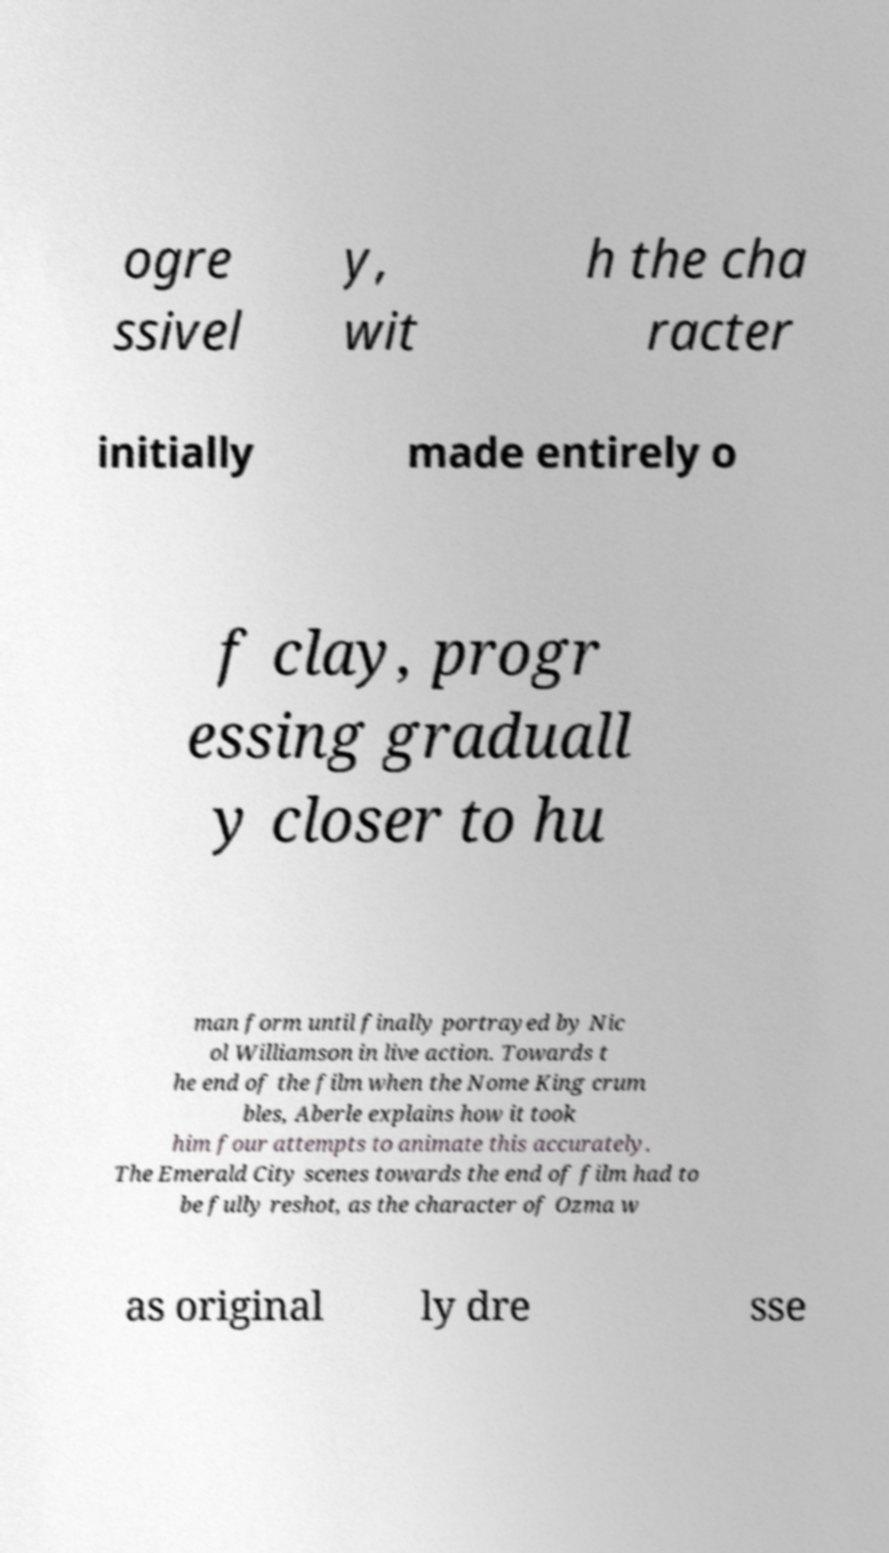Can you read and provide the text displayed in the image?This photo seems to have some interesting text. Can you extract and type it out for me? ogre ssivel y, wit h the cha racter initially made entirely o f clay, progr essing graduall y closer to hu man form until finally portrayed by Nic ol Williamson in live action. Towards t he end of the film when the Nome King crum bles, Aberle explains how it took him four attempts to animate this accurately. The Emerald City scenes towards the end of film had to be fully reshot, as the character of Ozma w as original ly dre sse 